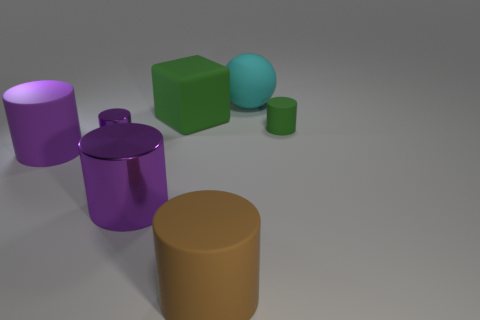What is the shape of the big green matte object? The shape of the big green object is a cube. Its surfaces are flat and it has six equal square faces, making it a perfect example of a three-dimensional cube. 